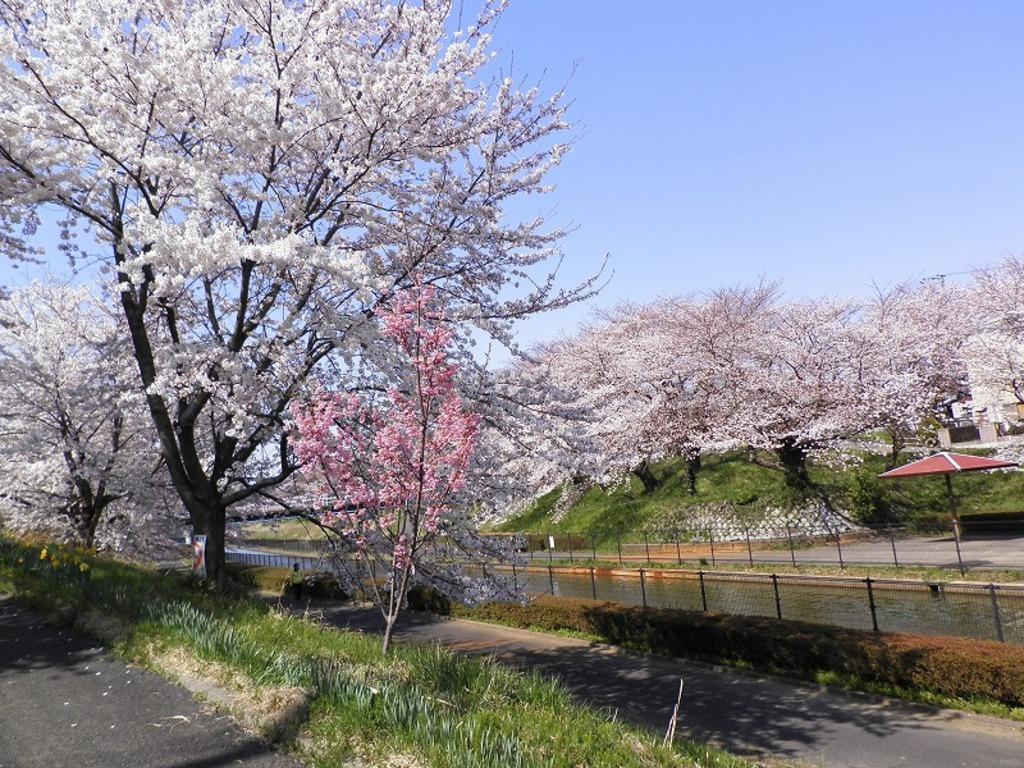How would you summarize this image in a sentence or two? In this image we can see plants, grass, flowers, fence and in the background we can see the sky. 